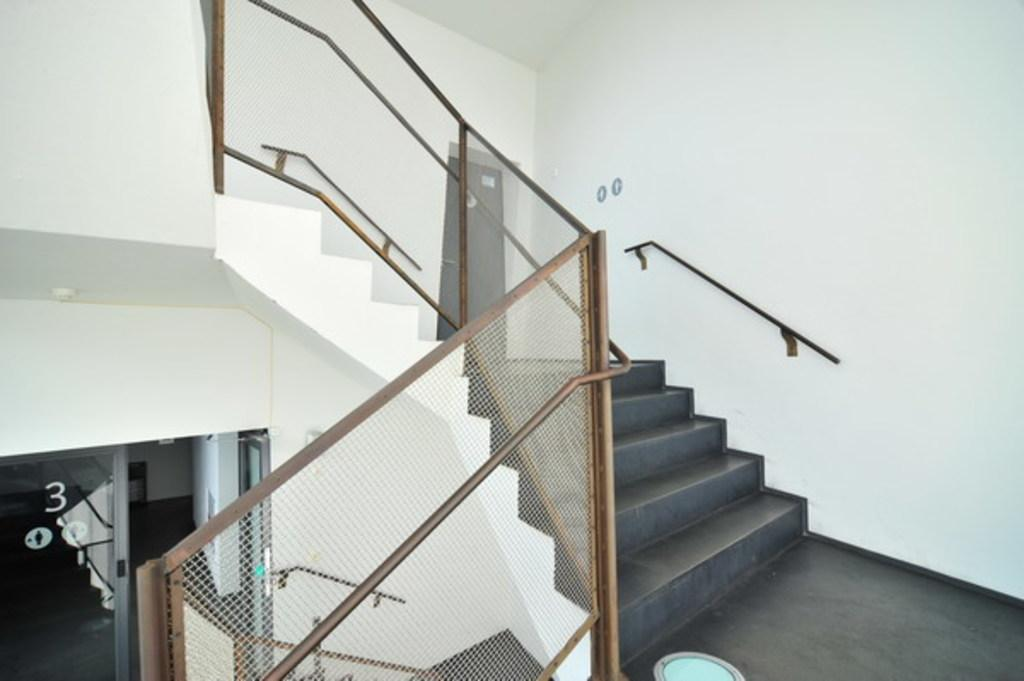What type of architectural feature is present in the image? There are stairs in the image. What safety feature is associated with the stairs? There is a railing associated with the stairs. What color is the wall visible in the image? The wall in the image is white-colored. What rule is being enforced by the planes in the image? There are no planes present in the image, so no rules can be enforced by them. 